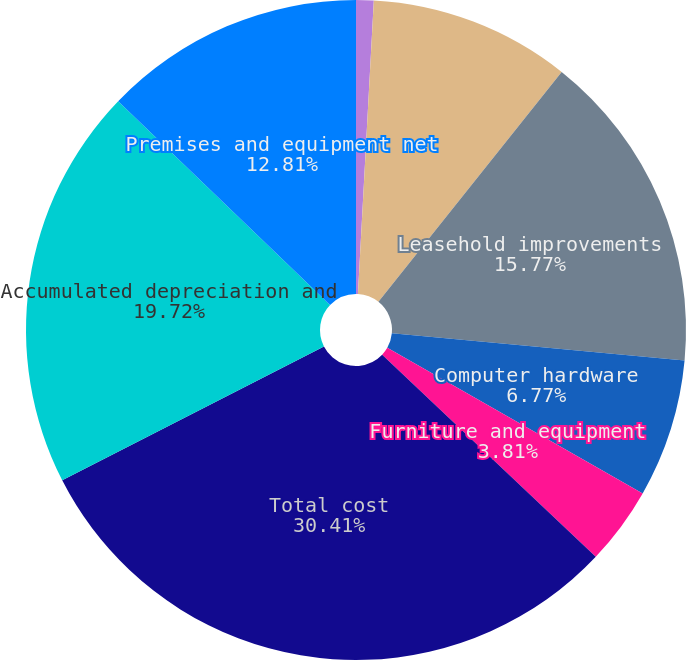<chart> <loc_0><loc_0><loc_500><loc_500><pie_chart><fcel>(Dollars in thousands)<fcel>Computer software<fcel>Leasehold improvements<fcel>Computer hardware<fcel>Furniture and equipment<fcel>Total cost<fcel>Accumulated depreciation and<fcel>Premises and equipment net<nl><fcel>0.86%<fcel>9.85%<fcel>15.77%<fcel>6.77%<fcel>3.81%<fcel>30.42%<fcel>19.72%<fcel>12.81%<nl></chart> 